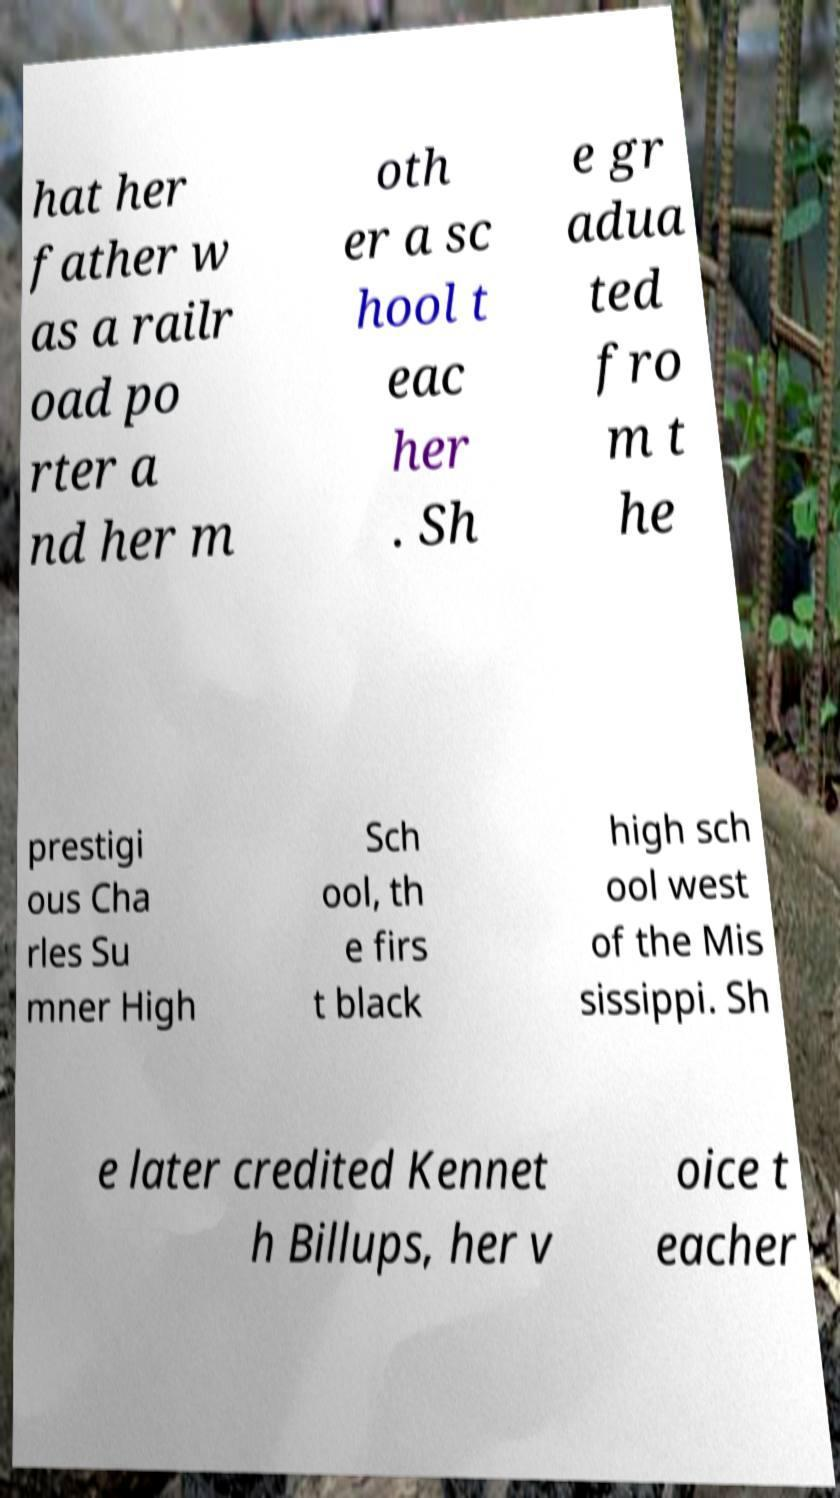Can you accurately transcribe the text from the provided image for me? hat her father w as a railr oad po rter a nd her m oth er a sc hool t eac her . Sh e gr adua ted fro m t he prestigi ous Cha rles Su mner High Sch ool, th e firs t black high sch ool west of the Mis sissippi. Sh e later credited Kennet h Billups, her v oice t eacher 